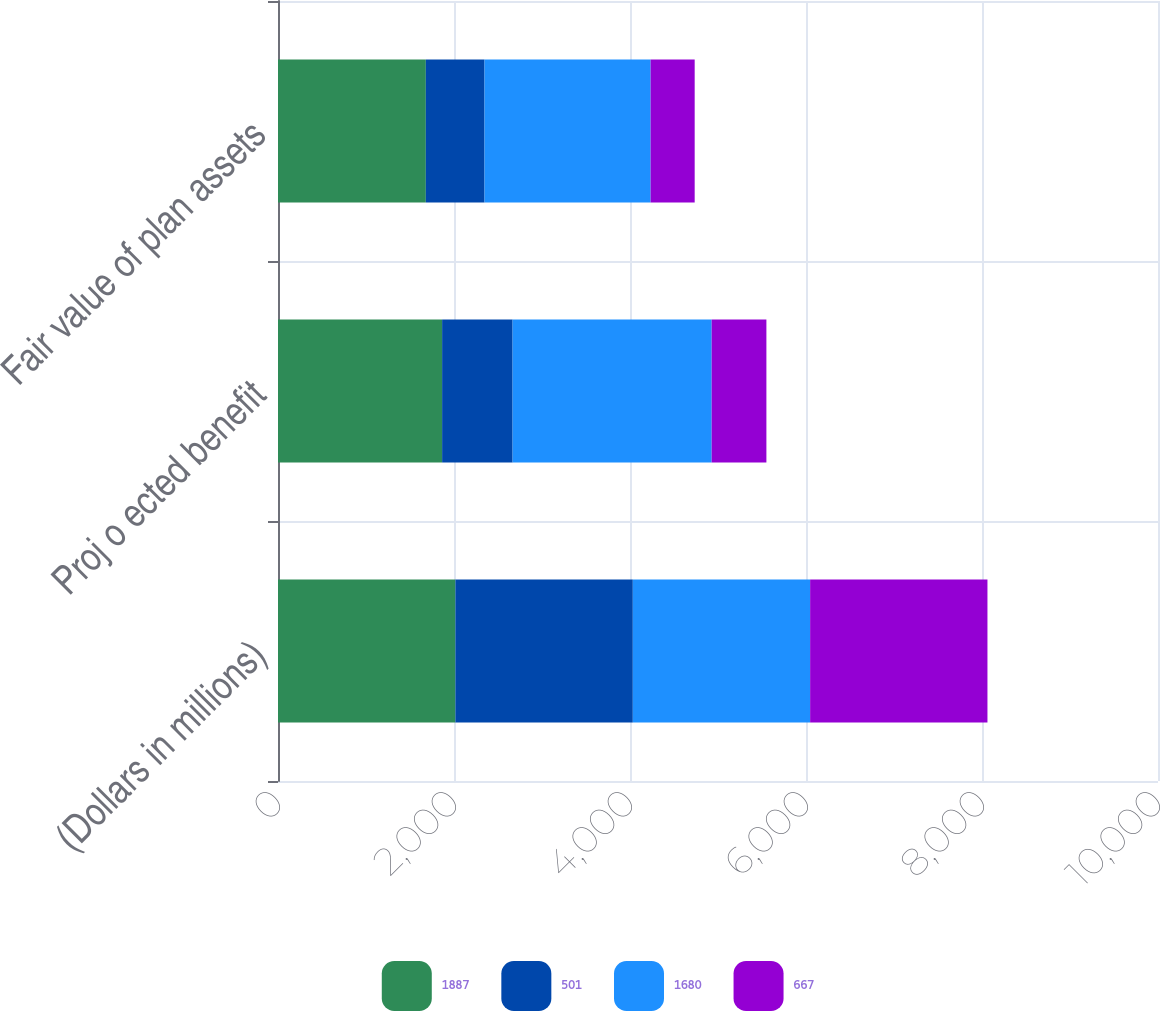Convert chart. <chart><loc_0><loc_0><loc_500><loc_500><stacked_bar_chart><ecel><fcel>(Dollars in millions)<fcel>Proj o ected benefit<fcel>Fair value of plan assets<nl><fcel>1887<fcel>2016<fcel>1865<fcel>1680<nl><fcel>501<fcel>2016<fcel>801<fcel>667<nl><fcel>1680<fcel>2015<fcel>2262<fcel>1887<nl><fcel>667<fcel>2015<fcel>622<fcel>501<nl></chart> 